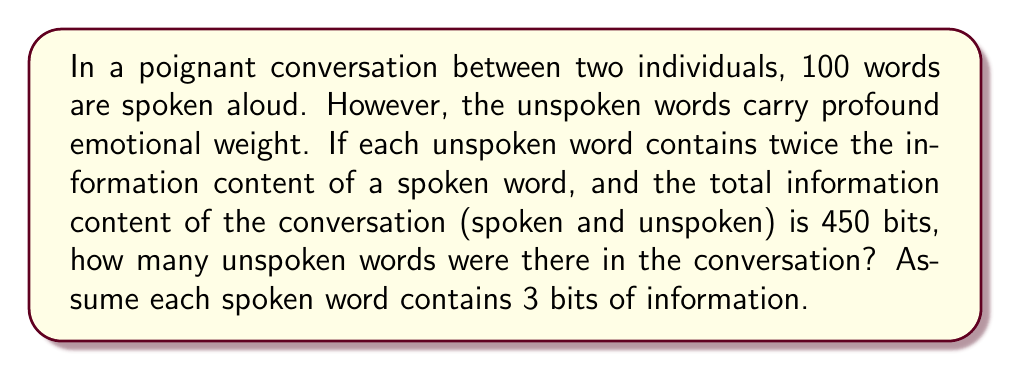Help me with this question. Let's approach this problem step by step:

1) First, let's define our variables:
   $s$ = number of spoken words (given as 100)
   $u$ = number of unspoken words (what we're solving for)
   $I_s$ = information content of a spoken word (given as 3 bits)
   $I_u$ = information content of an unspoken word (given as twice that of a spoken word)

2) We know that $I_u = 2I_s = 2 * 3 = 6$ bits

3) The total information content is given as 450 bits. We can express this as an equation:

   $$(s * I_s) + (u * I_u) = 450$$

4) Substituting our known values:

   $$(100 * 3) + (u * 6) = 450$$

5) Simplify:

   $$300 + 6u = 450$$

6) Subtract 300 from both sides:

   $$6u = 150$$

7) Divide both sides by 6:

   $$u = 25$$

Thus, there were 25 unspoken words in the conversation.

This result beautifully captures the essence of the poet's contemplation on unexpressed emotions. The unspoken words, though fewer in number, carry twice the information content, emphasizing the power and depth of what remains unsaid.
Answer: 25 unspoken words 